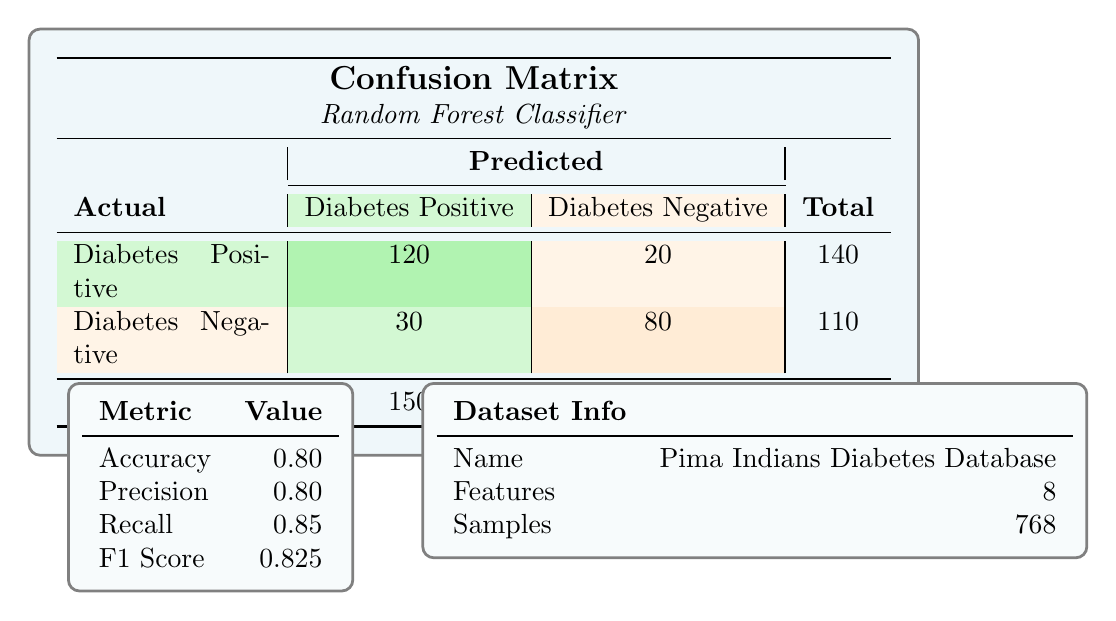What is the value of true positives in this confusion matrix? The table shows that the true positives, which represent the correctly predicted instances of "Diabetes Positive," is listed under the "Actual" row for "Diabetes Positive" and "Predicted" column for "Diabetes Positive," and that value is 120.
Answer: 120 How many total cases are there in the confusion matrix? The confusion matrix indicates that the total number of cases is shown in the last row under the total column, and that value is 250.
Answer: 250 What is the precision of the model? The precision value of the model is explicitly listed in the metrics table, and it is given as 0.80.
Answer: 0.80 Is the recall for the model greater than the precision? The recall, as noted in the metrics table, is 0.85 and the precision is 0.80. Since 0.85 is greater than 0.80, the statement is true.
Answer: Yes How many actual "Diabetes Negative" cases were predicted as "Diabetes Positive"? To find this, we look at the confusion matrix under the actual "Diabetes Negative" row and the predicted "Diabetes Positive" column, which indicates that 30 actual "Diabetes Negative" cases were incorrectly predicted as "Diabetes Positive."
Answer: 30 What is the F1 score and how does it relate to precision and recall? The F1 score is 0.825, indicated in the metrics table. The F1 score is the harmonic mean of precision and recall, which combines both metrics to provide a single measure of model performance, particularly emphasizing balance between them.
Answer: 0.825 What is the total number of false negatives and false positives combined? The total number of false negatives is given as 20 and false positives as 30. Adding these together gives 20 + 30 = 50.
Answer: 50 Is the accuracy higher than 75 percent? The accuracy is listed as 0.80, which translates to 80 percent. Since 80 percent is greater than 75 percent, the statement is true.
Answer: Yes How many total negative cases were predicted correctly? Looking at the confusion matrix, the total negative cases correspond to the actual "Diabetes Negative" row, and the number predicted correctly is 80, which is found in the "Diabetes Negative" column.
Answer: 80 